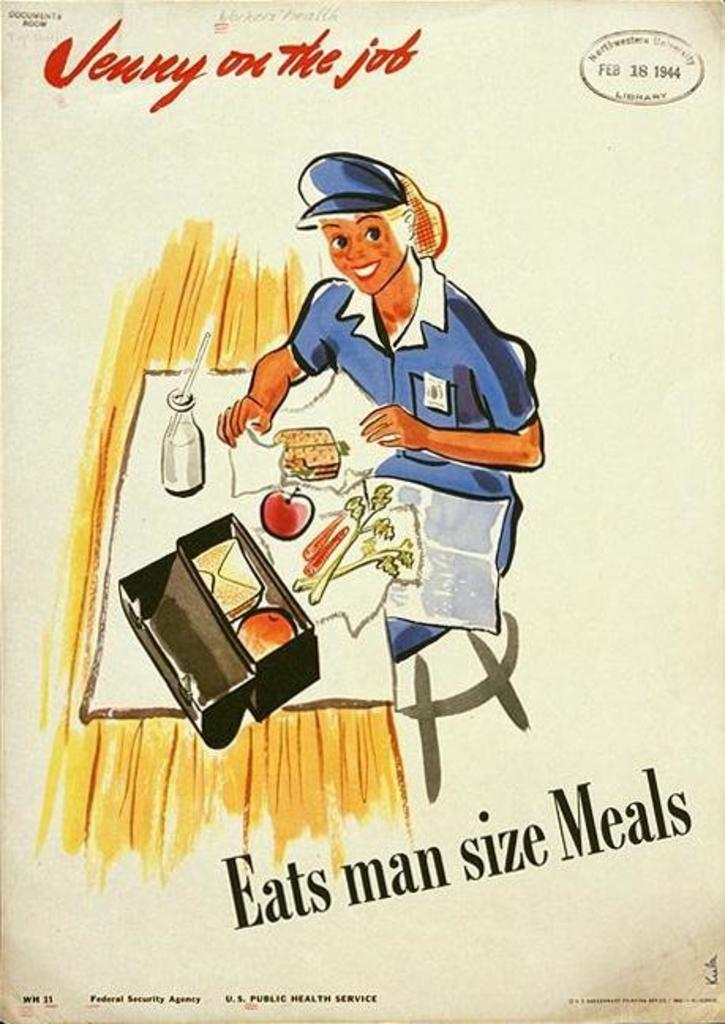<image>
Present a compact description of the photo's key features. Drawing of a woman making lunch and the phrase "eats man size meals" on the bottom. 